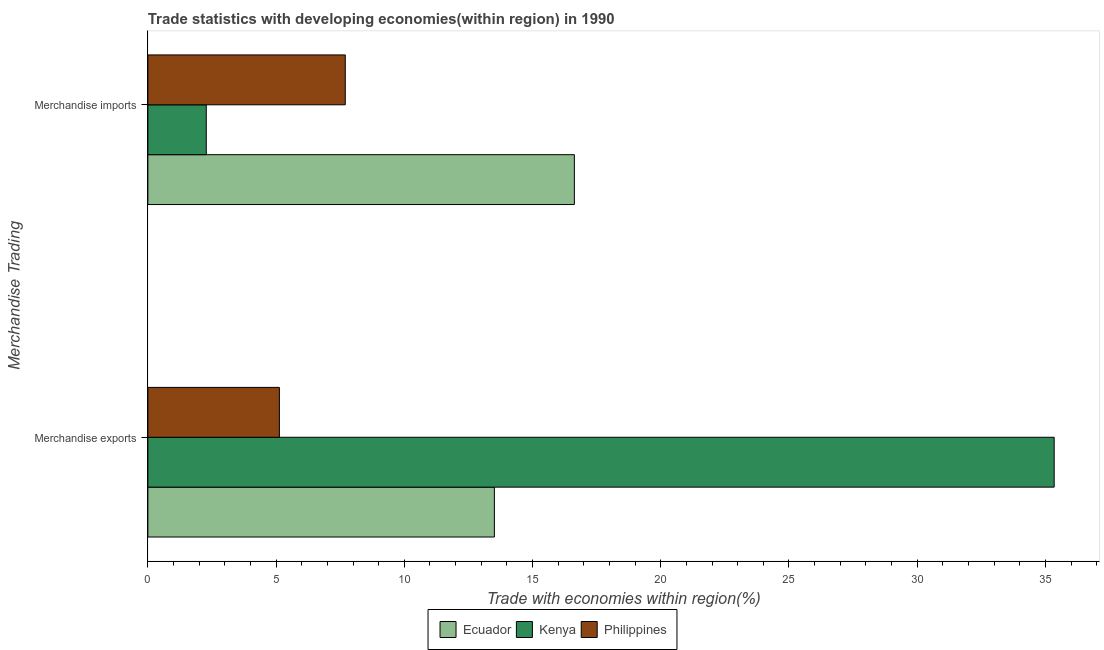How many groups of bars are there?
Your answer should be very brief. 2. How many bars are there on the 2nd tick from the bottom?
Provide a succinct answer. 3. What is the merchandise imports in Philippines?
Keep it short and to the point. 7.7. Across all countries, what is the maximum merchandise imports?
Give a very brief answer. 16.63. Across all countries, what is the minimum merchandise exports?
Keep it short and to the point. 5.13. In which country was the merchandise imports maximum?
Offer a very short reply. Ecuador. In which country was the merchandise imports minimum?
Offer a terse response. Kenya. What is the total merchandise exports in the graph?
Provide a succinct answer. 53.98. What is the difference between the merchandise exports in Philippines and that in Ecuador?
Your response must be concise. -8.38. What is the difference between the merchandise imports in Ecuador and the merchandise exports in Philippines?
Give a very brief answer. 11.5. What is the average merchandise imports per country?
Offer a very short reply. 8.87. What is the difference between the merchandise exports and merchandise imports in Ecuador?
Provide a succinct answer. -3.12. What is the ratio of the merchandise imports in Ecuador to that in Philippines?
Provide a succinct answer. 2.16. What does the 3rd bar from the top in Merchandise imports represents?
Give a very brief answer. Ecuador. What does the 3rd bar from the bottom in Merchandise exports represents?
Provide a short and direct response. Philippines. How many bars are there?
Make the answer very short. 6. Does the graph contain any zero values?
Make the answer very short. No. Does the graph contain grids?
Your answer should be compact. No. How are the legend labels stacked?
Ensure brevity in your answer.  Horizontal. What is the title of the graph?
Offer a terse response. Trade statistics with developing economies(within region) in 1990. What is the label or title of the X-axis?
Your response must be concise. Trade with economies within region(%). What is the label or title of the Y-axis?
Make the answer very short. Merchandise Trading. What is the Trade with economies within region(%) in Ecuador in Merchandise exports?
Keep it short and to the point. 13.51. What is the Trade with economies within region(%) in Kenya in Merchandise exports?
Provide a short and direct response. 35.34. What is the Trade with economies within region(%) in Philippines in Merchandise exports?
Your response must be concise. 5.13. What is the Trade with economies within region(%) of Ecuador in Merchandise imports?
Your answer should be compact. 16.63. What is the Trade with economies within region(%) in Kenya in Merchandise imports?
Make the answer very short. 2.28. What is the Trade with economies within region(%) of Philippines in Merchandise imports?
Make the answer very short. 7.7. Across all Merchandise Trading, what is the maximum Trade with economies within region(%) of Ecuador?
Give a very brief answer. 16.63. Across all Merchandise Trading, what is the maximum Trade with economies within region(%) of Kenya?
Keep it short and to the point. 35.34. Across all Merchandise Trading, what is the maximum Trade with economies within region(%) of Philippines?
Offer a terse response. 7.7. Across all Merchandise Trading, what is the minimum Trade with economies within region(%) in Ecuador?
Make the answer very short. 13.51. Across all Merchandise Trading, what is the minimum Trade with economies within region(%) in Kenya?
Keep it short and to the point. 2.28. Across all Merchandise Trading, what is the minimum Trade with economies within region(%) in Philippines?
Your answer should be compact. 5.13. What is the total Trade with economies within region(%) of Ecuador in the graph?
Offer a very short reply. 30.14. What is the total Trade with economies within region(%) in Kenya in the graph?
Provide a short and direct response. 37.62. What is the total Trade with economies within region(%) in Philippines in the graph?
Your answer should be very brief. 12.83. What is the difference between the Trade with economies within region(%) in Ecuador in Merchandise exports and that in Merchandise imports?
Your answer should be very brief. -3.12. What is the difference between the Trade with economies within region(%) of Kenya in Merchandise exports and that in Merchandise imports?
Provide a succinct answer. 33.06. What is the difference between the Trade with economies within region(%) of Philippines in Merchandise exports and that in Merchandise imports?
Offer a very short reply. -2.57. What is the difference between the Trade with economies within region(%) in Ecuador in Merchandise exports and the Trade with economies within region(%) in Kenya in Merchandise imports?
Ensure brevity in your answer.  11.23. What is the difference between the Trade with economies within region(%) in Ecuador in Merchandise exports and the Trade with economies within region(%) in Philippines in Merchandise imports?
Offer a very short reply. 5.81. What is the difference between the Trade with economies within region(%) in Kenya in Merchandise exports and the Trade with economies within region(%) in Philippines in Merchandise imports?
Make the answer very short. 27.64. What is the average Trade with economies within region(%) in Ecuador per Merchandise Trading?
Offer a very short reply. 15.07. What is the average Trade with economies within region(%) in Kenya per Merchandise Trading?
Your answer should be compact. 18.81. What is the average Trade with economies within region(%) in Philippines per Merchandise Trading?
Your answer should be very brief. 6.41. What is the difference between the Trade with economies within region(%) of Ecuador and Trade with economies within region(%) of Kenya in Merchandise exports?
Your response must be concise. -21.83. What is the difference between the Trade with economies within region(%) in Ecuador and Trade with economies within region(%) in Philippines in Merchandise exports?
Offer a terse response. 8.38. What is the difference between the Trade with economies within region(%) in Kenya and Trade with economies within region(%) in Philippines in Merchandise exports?
Your response must be concise. 30.21. What is the difference between the Trade with economies within region(%) of Ecuador and Trade with economies within region(%) of Kenya in Merchandise imports?
Ensure brevity in your answer.  14.35. What is the difference between the Trade with economies within region(%) of Ecuador and Trade with economies within region(%) of Philippines in Merchandise imports?
Provide a succinct answer. 8.93. What is the difference between the Trade with economies within region(%) of Kenya and Trade with economies within region(%) of Philippines in Merchandise imports?
Ensure brevity in your answer.  -5.42. What is the ratio of the Trade with economies within region(%) in Ecuador in Merchandise exports to that in Merchandise imports?
Make the answer very short. 0.81. What is the ratio of the Trade with economies within region(%) of Kenya in Merchandise exports to that in Merchandise imports?
Ensure brevity in your answer.  15.52. What is the ratio of the Trade with economies within region(%) in Philippines in Merchandise exports to that in Merchandise imports?
Your response must be concise. 0.67. What is the difference between the highest and the second highest Trade with economies within region(%) in Ecuador?
Make the answer very short. 3.12. What is the difference between the highest and the second highest Trade with economies within region(%) of Kenya?
Provide a succinct answer. 33.06. What is the difference between the highest and the second highest Trade with economies within region(%) of Philippines?
Your answer should be compact. 2.57. What is the difference between the highest and the lowest Trade with economies within region(%) in Ecuador?
Keep it short and to the point. 3.12. What is the difference between the highest and the lowest Trade with economies within region(%) of Kenya?
Your answer should be compact. 33.06. What is the difference between the highest and the lowest Trade with economies within region(%) of Philippines?
Make the answer very short. 2.57. 